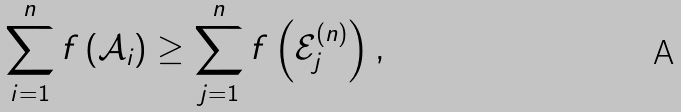<formula> <loc_0><loc_0><loc_500><loc_500>\sum _ { i = 1 } ^ { n } f \left ( \mathcal { A } _ { i } \right ) \geq \sum _ { j = 1 } ^ { n } f \left ( \mathcal { E } ^ { ( n ) } _ { j } \right ) ,</formula> 